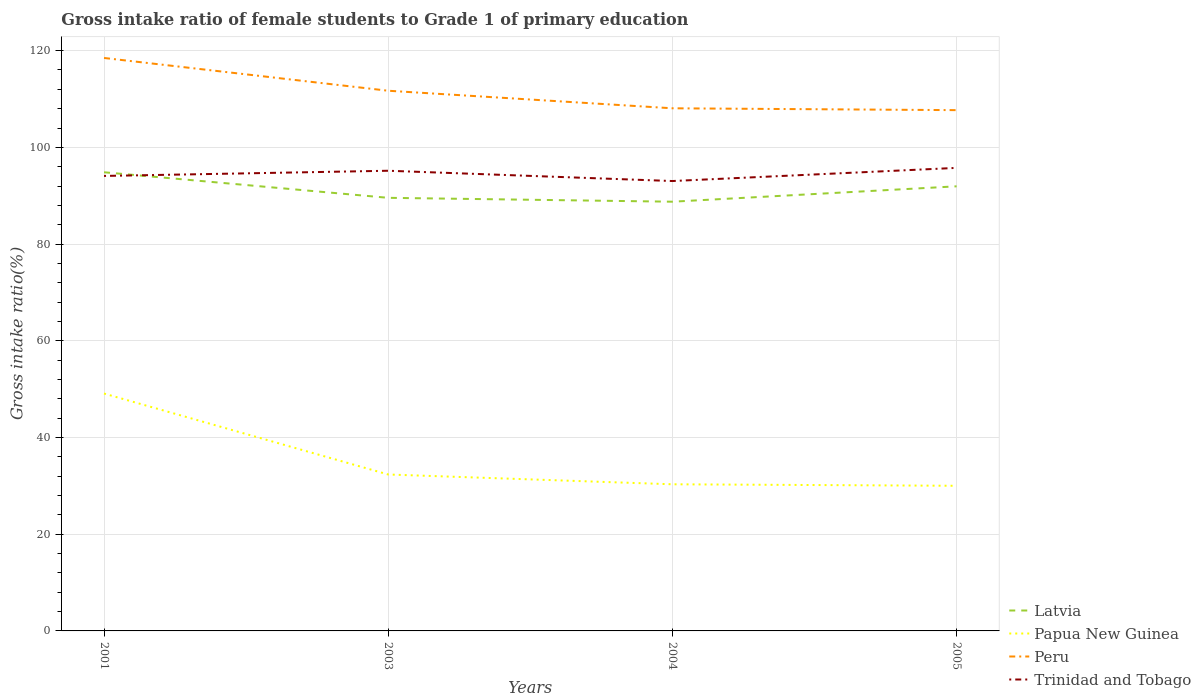How many different coloured lines are there?
Make the answer very short. 4. Across all years, what is the maximum gross intake ratio in Latvia?
Give a very brief answer. 88.76. What is the total gross intake ratio in Papua New Guinea in the graph?
Offer a terse response. 0.31. What is the difference between the highest and the second highest gross intake ratio in Latvia?
Provide a succinct answer. 6.09. What is the difference between the highest and the lowest gross intake ratio in Peru?
Your response must be concise. 2. Is the gross intake ratio in Trinidad and Tobago strictly greater than the gross intake ratio in Papua New Guinea over the years?
Keep it short and to the point. No. How many lines are there?
Offer a very short reply. 4. How many years are there in the graph?
Provide a succinct answer. 4. Are the values on the major ticks of Y-axis written in scientific E-notation?
Offer a very short reply. No. Does the graph contain any zero values?
Make the answer very short. No. Where does the legend appear in the graph?
Provide a short and direct response. Bottom right. How many legend labels are there?
Provide a short and direct response. 4. What is the title of the graph?
Provide a succinct answer. Gross intake ratio of female students to Grade 1 of primary education. Does "Burkina Faso" appear as one of the legend labels in the graph?
Provide a succinct answer. No. What is the label or title of the Y-axis?
Your response must be concise. Gross intake ratio(%). What is the Gross intake ratio(%) of Latvia in 2001?
Provide a short and direct response. 94.85. What is the Gross intake ratio(%) in Papua New Guinea in 2001?
Make the answer very short. 49.09. What is the Gross intake ratio(%) of Peru in 2001?
Ensure brevity in your answer.  118.48. What is the Gross intake ratio(%) in Trinidad and Tobago in 2001?
Your response must be concise. 94.09. What is the Gross intake ratio(%) in Latvia in 2003?
Your answer should be very brief. 89.56. What is the Gross intake ratio(%) of Papua New Guinea in 2003?
Make the answer very short. 32.35. What is the Gross intake ratio(%) of Peru in 2003?
Give a very brief answer. 111.7. What is the Gross intake ratio(%) in Trinidad and Tobago in 2003?
Offer a terse response. 95.16. What is the Gross intake ratio(%) of Latvia in 2004?
Keep it short and to the point. 88.76. What is the Gross intake ratio(%) of Papua New Guinea in 2004?
Offer a terse response. 30.32. What is the Gross intake ratio(%) of Peru in 2004?
Give a very brief answer. 108.07. What is the Gross intake ratio(%) of Trinidad and Tobago in 2004?
Your answer should be very brief. 93.03. What is the Gross intake ratio(%) in Latvia in 2005?
Give a very brief answer. 91.94. What is the Gross intake ratio(%) of Papua New Guinea in 2005?
Provide a succinct answer. 30.01. What is the Gross intake ratio(%) of Peru in 2005?
Make the answer very short. 107.69. What is the Gross intake ratio(%) of Trinidad and Tobago in 2005?
Offer a terse response. 95.75. Across all years, what is the maximum Gross intake ratio(%) of Latvia?
Your answer should be compact. 94.85. Across all years, what is the maximum Gross intake ratio(%) of Papua New Guinea?
Keep it short and to the point. 49.09. Across all years, what is the maximum Gross intake ratio(%) of Peru?
Make the answer very short. 118.48. Across all years, what is the maximum Gross intake ratio(%) in Trinidad and Tobago?
Your answer should be compact. 95.75. Across all years, what is the minimum Gross intake ratio(%) in Latvia?
Your answer should be compact. 88.76. Across all years, what is the minimum Gross intake ratio(%) in Papua New Guinea?
Make the answer very short. 30.01. Across all years, what is the minimum Gross intake ratio(%) in Peru?
Provide a short and direct response. 107.69. Across all years, what is the minimum Gross intake ratio(%) in Trinidad and Tobago?
Your answer should be very brief. 93.03. What is the total Gross intake ratio(%) of Latvia in the graph?
Give a very brief answer. 365.11. What is the total Gross intake ratio(%) in Papua New Guinea in the graph?
Make the answer very short. 141.77. What is the total Gross intake ratio(%) of Peru in the graph?
Your answer should be very brief. 445.95. What is the total Gross intake ratio(%) in Trinidad and Tobago in the graph?
Make the answer very short. 378.03. What is the difference between the Gross intake ratio(%) of Latvia in 2001 and that in 2003?
Make the answer very short. 5.28. What is the difference between the Gross intake ratio(%) in Papua New Guinea in 2001 and that in 2003?
Your answer should be compact. 16.74. What is the difference between the Gross intake ratio(%) in Peru in 2001 and that in 2003?
Your response must be concise. 6.78. What is the difference between the Gross intake ratio(%) in Trinidad and Tobago in 2001 and that in 2003?
Offer a terse response. -1.07. What is the difference between the Gross intake ratio(%) in Latvia in 2001 and that in 2004?
Provide a short and direct response. 6.09. What is the difference between the Gross intake ratio(%) in Papua New Guinea in 2001 and that in 2004?
Offer a very short reply. 18.76. What is the difference between the Gross intake ratio(%) of Peru in 2001 and that in 2004?
Offer a terse response. 10.41. What is the difference between the Gross intake ratio(%) of Trinidad and Tobago in 2001 and that in 2004?
Provide a succinct answer. 1.05. What is the difference between the Gross intake ratio(%) of Latvia in 2001 and that in 2005?
Offer a very short reply. 2.9. What is the difference between the Gross intake ratio(%) in Papua New Guinea in 2001 and that in 2005?
Offer a very short reply. 19.07. What is the difference between the Gross intake ratio(%) of Peru in 2001 and that in 2005?
Give a very brief answer. 10.79. What is the difference between the Gross intake ratio(%) of Trinidad and Tobago in 2001 and that in 2005?
Offer a very short reply. -1.67. What is the difference between the Gross intake ratio(%) of Latvia in 2003 and that in 2004?
Keep it short and to the point. 0.8. What is the difference between the Gross intake ratio(%) in Papua New Guinea in 2003 and that in 2004?
Ensure brevity in your answer.  2.03. What is the difference between the Gross intake ratio(%) of Peru in 2003 and that in 2004?
Your answer should be compact. 3.63. What is the difference between the Gross intake ratio(%) in Trinidad and Tobago in 2003 and that in 2004?
Provide a short and direct response. 2.13. What is the difference between the Gross intake ratio(%) of Latvia in 2003 and that in 2005?
Offer a very short reply. -2.38. What is the difference between the Gross intake ratio(%) in Papua New Guinea in 2003 and that in 2005?
Make the answer very short. 2.33. What is the difference between the Gross intake ratio(%) of Peru in 2003 and that in 2005?
Your answer should be compact. 4.01. What is the difference between the Gross intake ratio(%) in Trinidad and Tobago in 2003 and that in 2005?
Make the answer very short. -0.59. What is the difference between the Gross intake ratio(%) of Latvia in 2004 and that in 2005?
Make the answer very short. -3.18. What is the difference between the Gross intake ratio(%) of Papua New Guinea in 2004 and that in 2005?
Your answer should be very brief. 0.31. What is the difference between the Gross intake ratio(%) in Peru in 2004 and that in 2005?
Offer a very short reply. 0.38. What is the difference between the Gross intake ratio(%) of Trinidad and Tobago in 2004 and that in 2005?
Ensure brevity in your answer.  -2.72. What is the difference between the Gross intake ratio(%) of Latvia in 2001 and the Gross intake ratio(%) of Papua New Guinea in 2003?
Ensure brevity in your answer.  62.5. What is the difference between the Gross intake ratio(%) in Latvia in 2001 and the Gross intake ratio(%) in Peru in 2003?
Offer a very short reply. -16.86. What is the difference between the Gross intake ratio(%) in Latvia in 2001 and the Gross intake ratio(%) in Trinidad and Tobago in 2003?
Your response must be concise. -0.31. What is the difference between the Gross intake ratio(%) of Papua New Guinea in 2001 and the Gross intake ratio(%) of Peru in 2003?
Provide a short and direct response. -62.62. What is the difference between the Gross intake ratio(%) of Papua New Guinea in 2001 and the Gross intake ratio(%) of Trinidad and Tobago in 2003?
Provide a succinct answer. -46.07. What is the difference between the Gross intake ratio(%) in Peru in 2001 and the Gross intake ratio(%) in Trinidad and Tobago in 2003?
Provide a short and direct response. 23.32. What is the difference between the Gross intake ratio(%) of Latvia in 2001 and the Gross intake ratio(%) of Papua New Guinea in 2004?
Make the answer very short. 64.52. What is the difference between the Gross intake ratio(%) in Latvia in 2001 and the Gross intake ratio(%) in Peru in 2004?
Your answer should be very brief. -13.23. What is the difference between the Gross intake ratio(%) in Latvia in 2001 and the Gross intake ratio(%) in Trinidad and Tobago in 2004?
Your answer should be very brief. 1.81. What is the difference between the Gross intake ratio(%) in Papua New Guinea in 2001 and the Gross intake ratio(%) in Peru in 2004?
Ensure brevity in your answer.  -58.99. What is the difference between the Gross intake ratio(%) in Papua New Guinea in 2001 and the Gross intake ratio(%) in Trinidad and Tobago in 2004?
Give a very brief answer. -43.95. What is the difference between the Gross intake ratio(%) in Peru in 2001 and the Gross intake ratio(%) in Trinidad and Tobago in 2004?
Offer a very short reply. 25.45. What is the difference between the Gross intake ratio(%) in Latvia in 2001 and the Gross intake ratio(%) in Papua New Guinea in 2005?
Your answer should be very brief. 64.83. What is the difference between the Gross intake ratio(%) of Latvia in 2001 and the Gross intake ratio(%) of Peru in 2005?
Provide a short and direct response. -12.85. What is the difference between the Gross intake ratio(%) of Latvia in 2001 and the Gross intake ratio(%) of Trinidad and Tobago in 2005?
Make the answer very short. -0.91. What is the difference between the Gross intake ratio(%) of Papua New Guinea in 2001 and the Gross intake ratio(%) of Peru in 2005?
Your response must be concise. -58.61. What is the difference between the Gross intake ratio(%) in Papua New Guinea in 2001 and the Gross intake ratio(%) in Trinidad and Tobago in 2005?
Your response must be concise. -46.67. What is the difference between the Gross intake ratio(%) of Peru in 2001 and the Gross intake ratio(%) of Trinidad and Tobago in 2005?
Provide a succinct answer. 22.73. What is the difference between the Gross intake ratio(%) in Latvia in 2003 and the Gross intake ratio(%) in Papua New Guinea in 2004?
Keep it short and to the point. 59.24. What is the difference between the Gross intake ratio(%) in Latvia in 2003 and the Gross intake ratio(%) in Peru in 2004?
Give a very brief answer. -18.51. What is the difference between the Gross intake ratio(%) of Latvia in 2003 and the Gross intake ratio(%) of Trinidad and Tobago in 2004?
Your answer should be very brief. -3.47. What is the difference between the Gross intake ratio(%) of Papua New Guinea in 2003 and the Gross intake ratio(%) of Peru in 2004?
Provide a succinct answer. -75.73. What is the difference between the Gross intake ratio(%) in Papua New Guinea in 2003 and the Gross intake ratio(%) in Trinidad and Tobago in 2004?
Your response must be concise. -60.69. What is the difference between the Gross intake ratio(%) in Peru in 2003 and the Gross intake ratio(%) in Trinidad and Tobago in 2004?
Provide a short and direct response. 18.67. What is the difference between the Gross intake ratio(%) of Latvia in 2003 and the Gross intake ratio(%) of Papua New Guinea in 2005?
Ensure brevity in your answer.  59.55. What is the difference between the Gross intake ratio(%) of Latvia in 2003 and the Gross intake ratio(%) of Peru in 2005?
Offer a terse response. -18.13. What is the difference between the Gross intake ratio(%) of Latvia in 2003 and the Gross intake ratio(%) of Trinidad and Tobago in 2005?
Offer a terse response. -6.19. What is the difference between the Gross intake ratio(%) of Papua New Guinea in 2003 and the Gross intake ratio(%) of Peru in 2005?
Offer a terse response. -75.34. What is the difference between the Gross intake ratio(%) of Papua New Guinea in 2003 and the Gross intake ratio(%) of Trinidad and Tobago in 2005?
Provide a succinct answer. -63.41. What is the difference between the Gross intake ratio(%) of Peru in 2003 and the Gross intake ratio(%) of Trinidad and Tobago in 2005?
Keep it short and to the point. 15.95. What is the difference between the Gross intake ratio(%) of Latvia in 2004 and the Gross intake ratio(%) of Papua New Guinea in 2005?
Your answer should be compact. 58.75. What is the difference between the Gross intake ratio(%) of Latvia in 2004 and the Gross intake ratio(%) of Peru in 2005?
Offer a terse response. -18.93. What is the difference between the Gross intake ratio(%) of Latvia in 2004 and the Gross intake ratio(%) of Trinidad and Tobago in 2005?
Provide a short and direct response. -6.99. What is the difference between the Gross intake ratio(%) of Papua New Guinea in 2004 and the Gross intake ratio(%) of Peru in 2005?
Your answer should be very brief. -77.37. What is the difference between the Gross intake ratio(%) in Papua New Guinea in 2004 and the Gross intake ratio(%) in Trinidad and Tobago in 2005?
Give a very brief answer. -65.43. What is the difference between the Gross intake ratio(%) of Peru in 2004 and the Gross intake ratio(%) of Trinidad and Tobago in 2005?
Make the answer very short. 12.32. What is the average Gross intake ratio(%) of Latvia per year?
Make the answer very short. 91.28. What is the average Gross intake ratio(%) of Papua New Guinea per year?
Keep it short and to the point. 35.44. What is the average Gross intake ratio(%) in Peru per year?
Provide a short and direct response. 111.49. What is the average Gross intake ratio(%) in Trinidad and Tobago per year?
Ensure brevity in your answer.  94.51. In the year 2001, what is the difference between the Gross intake ratio(%) in Latvia and Gross intake ratio(%) in Papua New Guinea?
Your response must be concise. 45.76. In the year 2001, what is the difference between the Gross intake ratio(%) in Latvia and Gross intake ratio(%) in Peru?
Make the answer very short. -23.64. In the year 2001, what is the difference between the Gross intake ratio(%) of Latvia and Gross intake ratio(%) of Trinidad and Tobago?
Ensure brevity in your answer.  0.76. In the year 2001, what is the difference between the Gross intake ratio(%) in Papua New Guinea and Gross intake ratio(%) in Peru?
Make the answer very short. -69.4. In the year 2001, what is the difference between the Gross intake ratio(%) in Papua New Guinea and Gross intake ratio(%) in Trinidad and Tobago?
Ensure brevity in your answer.  -45. In the year 2001, what is the difference between the Gross intake ratio(%) of Peru and Gross intake ratio(%) of Trinidad and Tobago?
Give a very brief answer. 24.4. In the year 2003, what is the difference between the Gross intake ratio(%) in Latvia and Gross intake ratio(%) in Papua New Guinea?
Your answer should be compact. 57.21. In the year 2003, what is the difference between the Gross intake ratio(%) of Latvia and Gross intake ratio(%) of Peru?
Provide a succinct answer. -22.14. In the year 2003, what is the difference between the Gross intake ratio(%) in Latvia and Gross intake ratio(%) in Trinidad and Tobago?
Ensure brevity in your answer.  -5.6. In the year 2003, what is the difference between the Gross intake ratio(%) of Papua New Guinea and Gross intake ratio(%) of Peru?
Ensure brevity in your answer.  -79.36. In the year 2003, what is the difference between the Gross intake ratio(%) of Papua New Guinea and Gross intake ratio(%) of Trinidad and Tobago?
Ensure brevity in your answer.  -62.81. In the year 2003, what is the difference between the Gross intake ratio(%) of Peru and Gross intake ratio(%) of Trinidad and Tobago?
Offer a terse response. 16.54. In the year 2004, what is the difference between the Gross intake ratio(%) in Latvia and Gross intake ratio(%) in Papua New Guinea?
Give a very brief answer. 58.44. In the year 2004, what is the difference between the Gross intake ratio(%) in Latvia and Gross intake ratio(%) in Peru?
Ensure brevity in your answer.  -19.31. In the year 2004, what is the difference between the Gross intake ratio(%) in Latvia and Gross intake ratio(%) in Trinidad and Tobago?
Your answer should be very brief. -4.27. In the year 2004, what is the difference between the Gross intake ratio(%) of Papua New Guinea and Gross intake ratio(%) of Peru?
Keep it short and to the point. -77.75. In the year 2004, what is the difference between the Gross intake ratio(%) in Papua New Guinea and Gross intake ratio(%) in Trinidad and Tobago?
Ensure brevity in your answer.  -62.71. In the year 2004, what is the difference between the Gross intake ratio(%) of Peru and Gross intake ratio(%) of Trinidad and Tobago?
Your response must be concise. 15.04. In the year 2005, what is the difference between the Gross intake ratio(%) of Latvia and Gross intake ratio(%) of Papua New Guinea?
Your answer should be very brief. 61.93. In the year 2005, what is the difference between the Gross intake ratio(%) in Latvia and Gross intake ratio(%) in Peru?
Keep it short and to the point. -15.75. In the year 2005, what is the difference between the Gross intake ratio(%) of Latvia and Gross intake ratio(%) of Trinidad and Tobago?
Your response must be concise. -3.81. In the year 2005, what is the difference between the Gross intake ratio(%) of Papua New Guinea and Gross intake ratio(%) of Peru?
Your answer should be compact. -77.68. In the year 2005, what is the difference between the Gross intake ratio(%) in Papua New Guinea and Gross intake ratio(%) in Trinidad and Tobago?
Give a very brief answer. -65.74. In the year 2005, what is the difference between the Gross intake ratio(%) of Peru and Gross intake ratio(%) of Trinidad and Tobago?
Ensure brevity in your answer.  11.94. What is the ratio of the Gross intake ratio(%) in Latvia in 2001 to that in 2003?
Your response must be concise. 1.06. What is the ratio of the Gross intake ratio(%) of Papua New Guinea in 2001 to that in 2003?
Offer a terse response. 1.52. What is the ratio of the Gross intake ratio(%) of Peru in 2001 to that in 2003?
Your response must be concise. 1.06. What is the ratio of the Gross intake ratio(%) of Trinidad and Tobago in 2001 to that in 2003?
Ensure brevity in your answer.  0.99. What is the ratio of the Gross intake ratio(%) in Latvia in 2001 to that in 2004?
Your answer should be compact. 1.07. What is the ratio of the Gross intake ratio(%) of Papua New Guinea in 2001 to that in 2004?
Provide a short and direct response. 1.62. What is the ratio of the Gross intake ratio(%) in Peru in 2001 to that in 2004?
Ensure brevity in your answer.  1.1. What is the ratio of the Gross intake ratio(%) in Trinidad and Tobago in 2001 to that in 2004?
Keep it short and to the point. 1.01. What is the ratio of the Gross intake ratio(%) in Latvia in 2001 to that in 2005?
Keep it short and to the point. 1.03. What is the ratio of the Gross intake ratio(%) of Papua New Guinea in 2001 to that in 2005?
Your answer should be compact. 1.64. What is the ratio of the Gross intake ratio(%) of Peru in 2001 to that in 2005?
Give a very brief answer. 1.1. What is the ratio of the Gross intake ratio(%) in Trinidad and Tobago in 2001 to that in 2005?
Your response must be concise. 0.98. What is the ratio of the Gross intake ratio(%) of Latvia in 2003 to that in 2004?
Ensure brevity in your answer.  1.01. What is the ratio of the Gross intake ratio(%) of Papua New Guinea in 2003 to that in 2004?
Offer a very short reply. 1.07. What is the ratio of the Gross intake ratio(%) of Peru in 2003 to that in 2004?
Your response must be concise. 1.03. What is the ratio of the Gross intake ratio(%) in Trinidad and Tobago in 2003 to that in 2004?
Provide a short and direct response. 1.02. What is the ratio of the Gross intake ratio(%) in Latvia in 2003 to that in 2005?
Your answer should be compact. 0.97. What is the ratio of the Gross intake ratio(%) of Papua New Guinea in 2003 to that in 2005?
Ensure brevity in your answer.  1.08. What is the ratio of the Gross intake ratio(%) of Peru in 2003 to that in 2005?
Provide a short and direct response. 1.04. What is the ratio of the Gross intake ratio(%) in Latvia in 2004 to that in 2005?
Make the answer very short. 0.97. What is the ratio of the Gross intake ratio(%) in Papua New Guinea in 2004 to that in 2005?
Provide a succinct answer. 1.01. What is the ratio of the Gross intake ratio(%) of Trinidad and Tobago in 2004 to that in 2005?
Give a very brief answer. 0.97. What is the difference between the highest and the second highest Gross intake ratio(%) in Latvia?
Offer a terse response. 2.9. What is the difference between the highest and the second highest Gross intake ratio(%) of Papua New Guinea?
Offer a very short reply. 16.74. What is the difference between the highest and the second highest Gross intake ratio(%) in Peru?
Offer a very short reply. 6.78. What is the difference between the highest and the second highest Gross intake ratio(%) of Trinidad and Tobago?
Your response must be concise. 0.59. What is the difference between the highest and the lowest Gross intake ratio(%) of Latvia?
Keep it short and to the point. 6.09. What is the difference between the highest and the lowest Gross intake ratio(%) of Papua New Guinea?
Offer a terse response. 19.07. What is the difference between the highest and the lowest Gross intake ratio(%) in Peru?
Provide a short and direct response. 10.79. What is the difference between the highest and the lowest Gross intake ratio(%) of Trinidad and Tobago?
Provide a short and direct response. 2.72. 